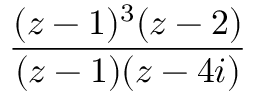<formula> <loc_0><loc_0><loc_500><loc_500>\frac { ( z - 1 ) ^ { 3 } ( z - 2 ) } { ( z - 1 ) ( z - 4 i ) }</formula> 